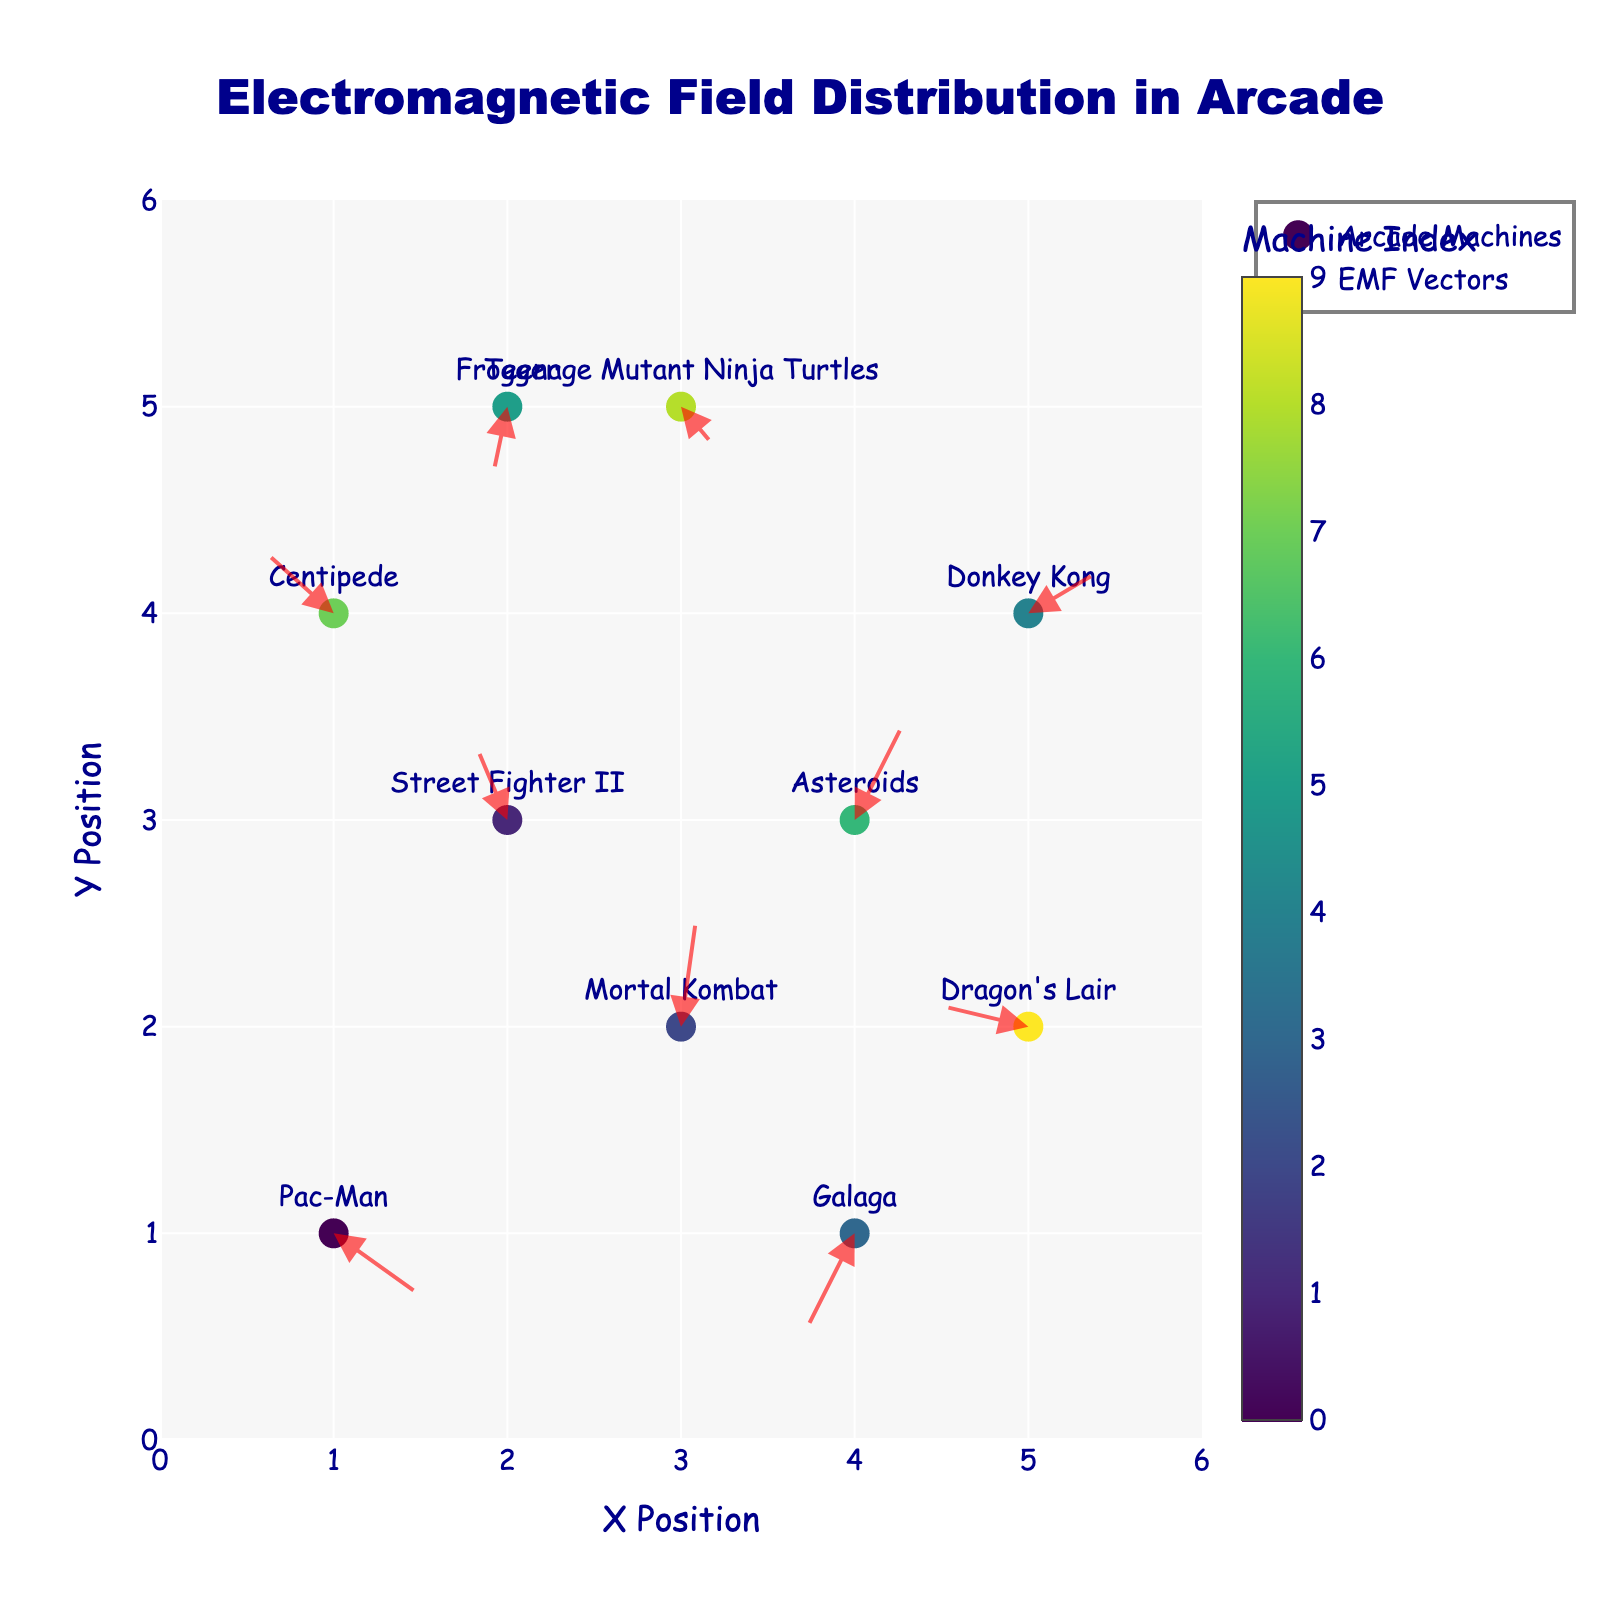How many arcade machines are displayed in the plot? By identifying and counting the number of unique markers and labels on the plot, we can determine the number of arcade machines. Each machine corresponds to one marker with a text label.
Answer: 10 What is the direction of the EMF vector for Pac-Man? Locate the Pac-Man machine on the plot at coordinates (1,1) and observe the direction of the arrow originating from it. The vector has components (0.5, -0.3). Thus, it points to the right and slightly downward.
Answer: Right and downward Which machine has the largest upward EMF vector component? Analyze the vertical components (V) of all vectors on the plot. The machine at (3,2) with a vector of (0.1, 0.6) has the highest upward vertical component of 0.6.
Answer: Mortal Kombat Are there any machines that have an EMF vector in the negative X direction? Check the horizontal components (U) of the vectors on the plot. Machines with negative U components have vectors in the negative X direction. Machines at (2,3), (4,1), (2,5), and (5,2) qualify.
Answer: Yes What is the sum of the horizontal EMF components (U) for all machines? Sum the U components from each machine: 0.5 + (-0.2) + 0.1 + (-0.3) + 0.4 + (-0.1) + 0.3 + (-0.4) + 0.2 + (-0.5) = 0
Answer: 0 Which machine has the closest vector direction to Donkey Kong? Compare the vectors' directions (components) and identify the machine with a vector most similar to Donkey Kong’s (0.4, 0.2) at (5,4). Asteroids' vector (0.3, 0.5) at (4,3) is closest by direction (both point upward and rightward).
Answer: Asteroids Is there any interference zone where more than one machine's EMF vectors overlap? Check for areas where arrows from different machines overlap or closely align. Machines at (4, 3) and (1, 1) arrows moderately point to each other’s areas, suggesting potential overlap and interference.
Answer: Yes Which machine has the largest resultant vector magnitude? Calculate the magnitudes sqrt(U²+V²) for each machine and identify the largest. For Mortal Kombat (0.1, 0.6), the magnitude is sqrt(0.1² + 0.6²) ≈ 0.61, which is the largest.
Answer: Mortal Kombat 